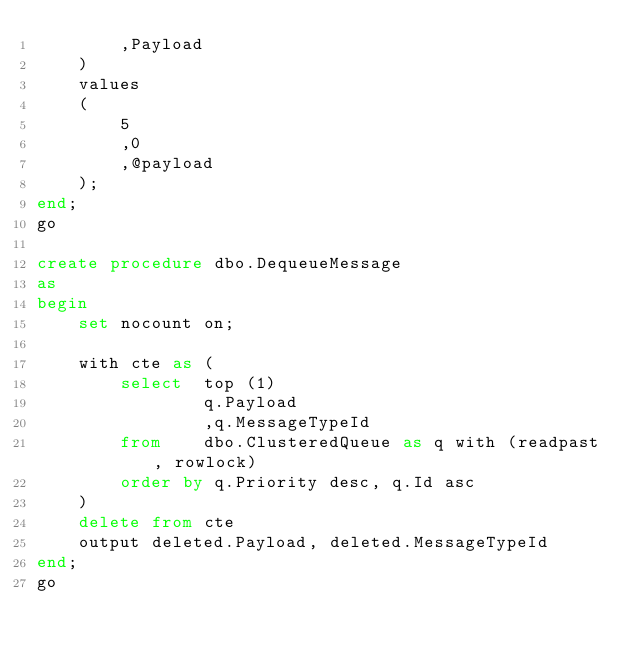<code> <loc_0><loc_0><loc_500><loc_500><_SQL_>		,Payload
	)
	values
	(
		5
		,0
		,@payload
	);
end;
go

create procedure dbo.DequeueMessage
as
begin
	set nocount on;

	with cte as (
		select 	top (1)
				q.Payload
				,q.MessageTypeId
		from	dbo.ClusteredQueue as q with (readpast, rowlock)
		order by q.Priority desc, q.Id asc
	)
	delete from cte
	output deleted.Payload, deleted.MessageTypeId
end;
go</code> 